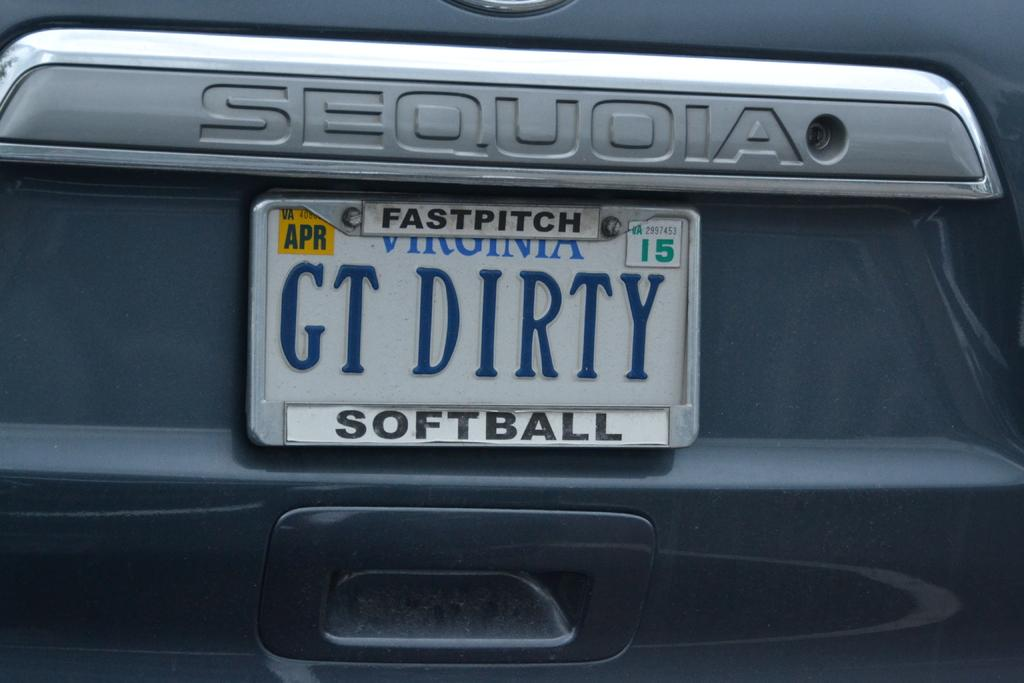<image>
Share a concise interpretation of the image provided. A car has a fast pitch softball license plate holder on it. 